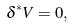Convert formula to latex. <formula><loc_0><loc_0><loc_500><loc_500>\delta ^ { * } V = 0 ,</formula> 